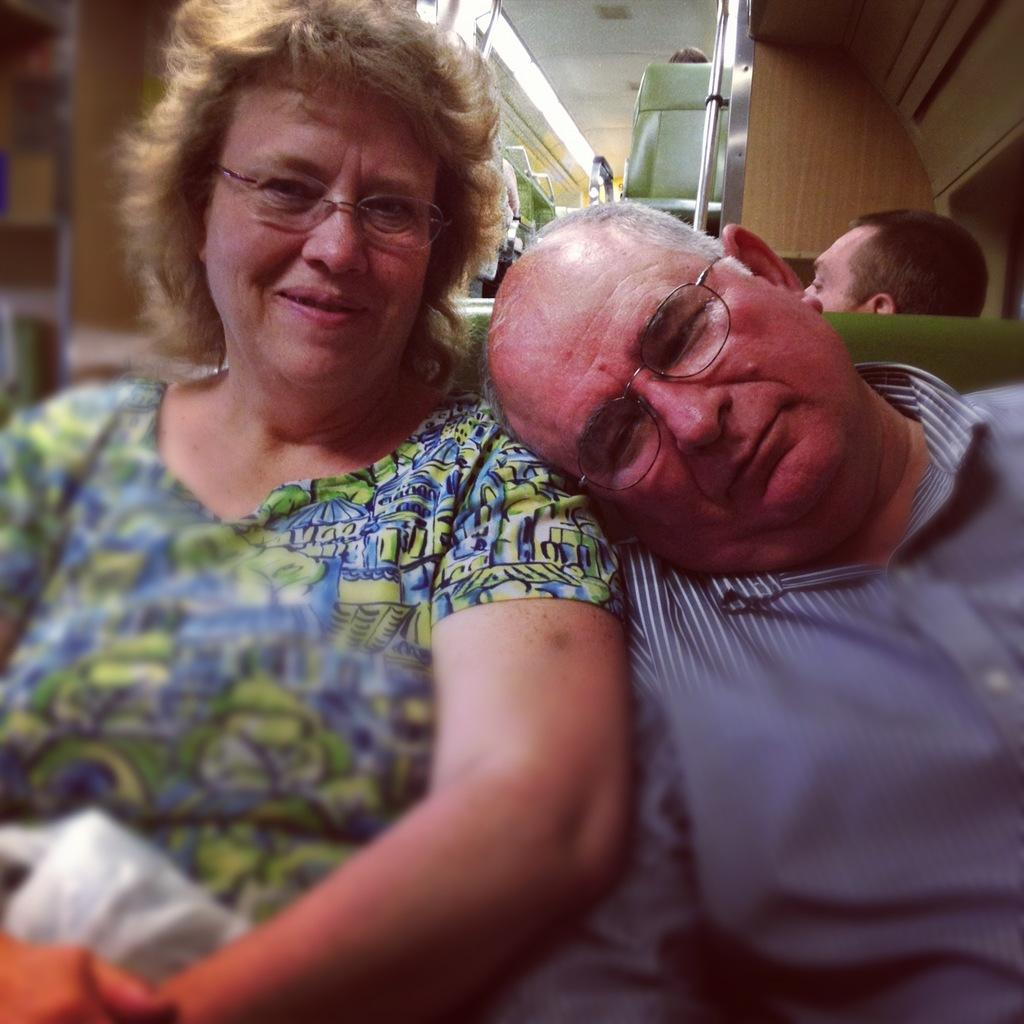Who are the two people in the image? There is a man and a woman in the image. What are they doing in the image? The man and woman are sitting on a vehicle seat, and the man is lying on the woman's shoulder. Can you describe the background of the image? There are other persons visible in the background of the image, and there are additional seats as well. What are the children's interests in the image? There are no children present in the image, so their interests cannot be determined. 